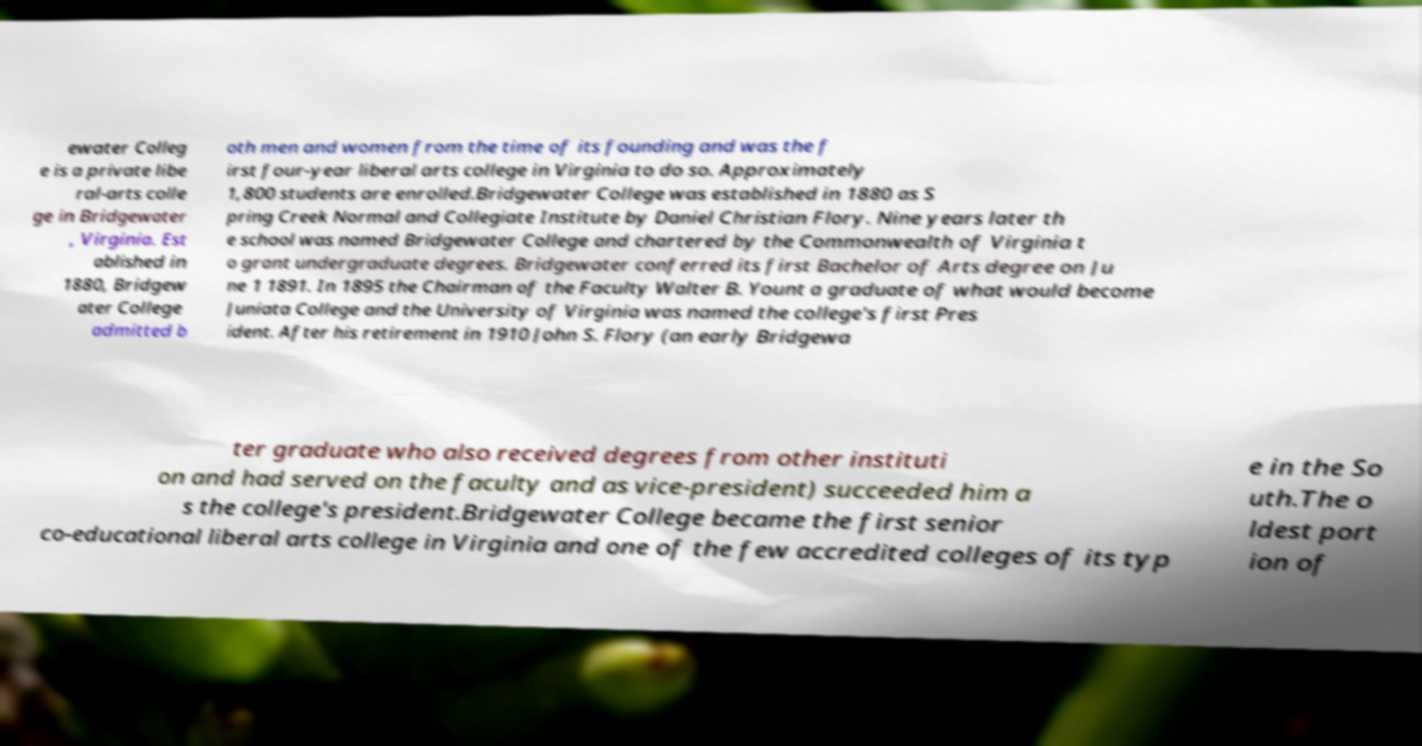Please read and relay the text visible in this image. What does it say? ewater Colleg e is a private libe ral-arts colle ge in Bridgewater , Virginia. Est ablished in 1880, Bridgew ater College admitted b oth men and women from the time of its founding and was the f irst four-year liberal arts college in Virginia to do so. Approximately 1,800 students are enrolled.Bridgewater College was established in 1880 as S pring Creek Normal and Collegiate Institute by Daniel Christian Flory. Nine years later th e school was named Bridgewater College and chartered by the Commonwealth of Virginia t o grant undergraduate degrees. Bridgewater conferred its first Bachelor of Arts degree on Ju ne 1 1891. In 1895 the Chairman of the Faculty Walter B. Yount a graduate of what would become Juniata College and the University of Virginia was named the college's first Pres ident. After his retirement in 1910 John S. Flory (an early Bridgewa ter graduate who also received degrees from other instituti on and had served on the faculty and as vice-president) succeeded him a s the college's president.Bridgewater College became the first senior co-educational liberal arts college in Virginia and one of the few accredited colleges of its typ e in the So uth.The o ldest port ion of 